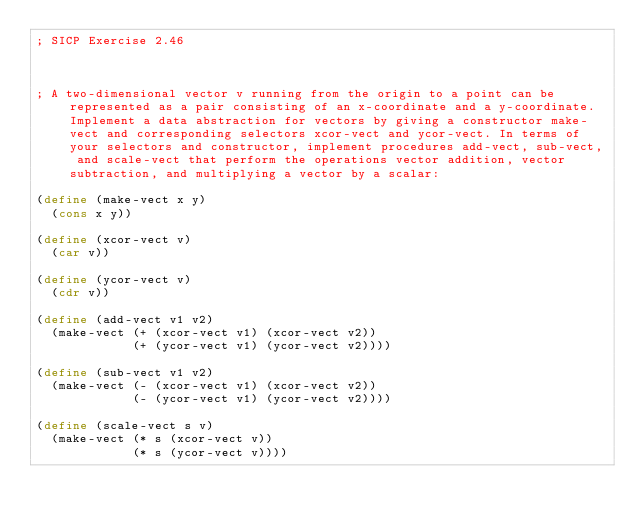Convert code to text. <code><loc_0><loc_0><loc_500><loc_500><_Scheme_>; SICP Exercise 2.46



; A two-dimensional vector v running from the origin to a point can be represented as a pair consisting of an x-coordinate and a y-coordinate. Implement a data abstraction for vectors by giving a constructor make-vect and corresponding selectors xcor-vect and ycor-vect. In terms of your selectors and constructor, implement procedures add-vect, sub-vect, and scale-vect that perform the operations vector addition, vector subtraction, and multiplying a vector by a scalar:

(define (make-vect x y)
  (cons x y))

(define (xcor-vect v)
  (car v))

(define (ycor-vect v)
  (cdr v))

(define (add-vect v1 v2)
  (make-vect (+ (xcor-vect v1) (xcor-vect v2))
             (+ (ycor-vect v1) (ycor-vect v2))))

(define (sub-vect v1 v2)
  (make-vect (- (xcor-vect v1) (xcor-vect v2))
             (- (ycor-vect v1) (ycor-vect v2))))

(define (scale-vect s v)
  (make-vect (* s (xcor-vect v))
             (* s (ycor-vect v))))
</code> 